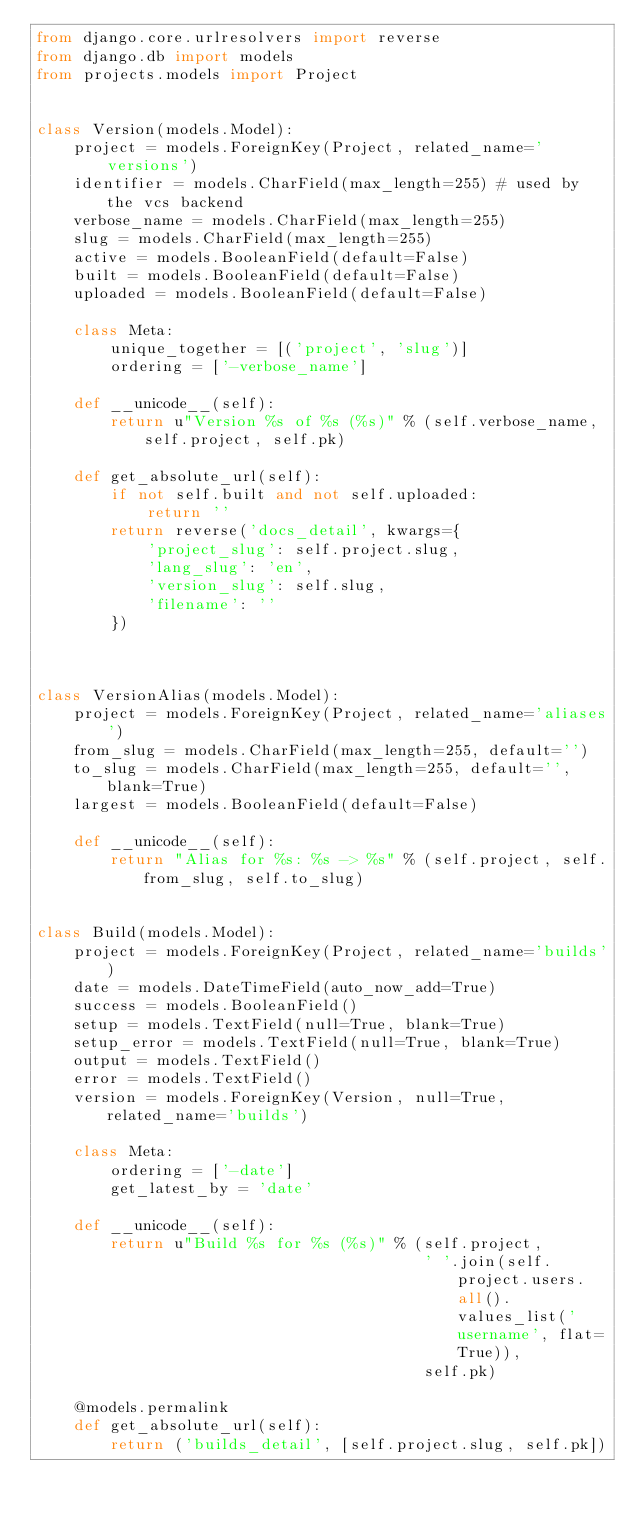<code> <loc_0><loc_0><loc_500><loc_500><_Python_>from django.core.urlresolvers import reverse
from django.db import models
from projects.models import Project


class Version(models.Model):
    project = models.ForeignKey(Project, related_name='versions')
    identifier = models.CharField(max_length=255) # used by the vcs backend
    verbose_name = models.CharField(max_length=255)
    slug = models.CharField(max_length=255)
    active = models.BooleanField(default=False)
    built = models.BooleanField(default=False)
    uploaded = models.BooleanField(default=False)

    class Meta:
        unique_together = [('project', 'slug')]
        ordering = ['-verbose_name']

    def __unicode__(self):
        return u"Version %s of %s (%s)" % (self.verbose_name, self.project, self.pk)

    def get_absolute_url(self):
        if not self.built and not self.uploaded:
            return ''
        return reverse('docs_detail', kwargs={
            'project_slug': self.project.slug,
            'lang_slug': 'en',
            'version_slug': self.slug,
            'filename': ''
        })



class VersionAlias(models.Model):
    project = models.ForeignKey(Project, related_name='aliases')
    from_slug = models.CharField(max_length=255, default='')
    to_slug = models.CharField(max_length=255, default='', blank=True)
    largest = models.BooleanField(default=False)

    def __unicode__(self):
        return "Alias for %s: %s -> %s" % (self.project, self.from_slug, self.to_slug)


class Build(models.Model):
    project = models.ForeignKey(Project, related_name='builds')
    date = models.DateTimeField(auto_now_add=True)
    success = models.BooleanField()
    setup = models.TextField(null=True, blank=True)
    setup_error = models.TextField(null=True, blank=True)
    output = models.TextField()
    error = models.TextField()
    version = models.ForeignKey(Version, null=True, related_name='builds')

    class Meta:
        ordering = ['-date']
        get_latest_by = 'date'

    def __unicode__(self):
        return u"Build %s for %s (%s)" % (self.project,
                                          ' '.join(self.project.users.all().values_list('username', flat=True)),
                                          self.pk)

    @models.permalink
    def get_absolute_url(self):
        return ('builds_detail', [self.project.slug, self.pk])
</code> 